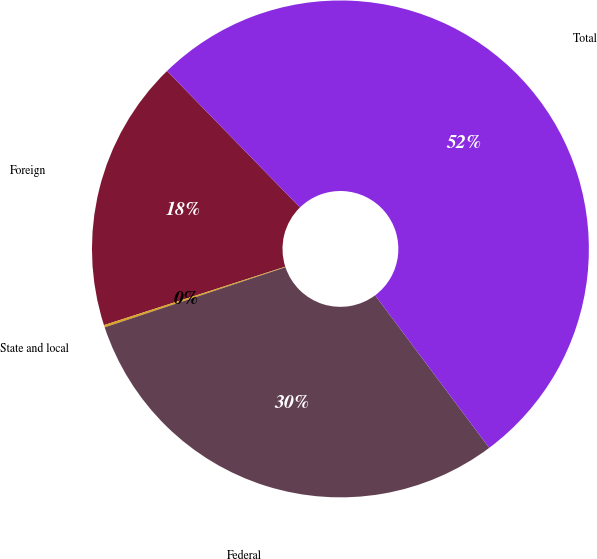Convert chart. <chart><loc_0><loc_0><loc_500><loc_500><pie_chart><fcel>Foreign<fcel>State and local<fcel>Federal<fcel>Total<nl><fcel>17.67%<fcel>0.15%<fcel>30.11%<fcel>52.07%<nl></chart> 